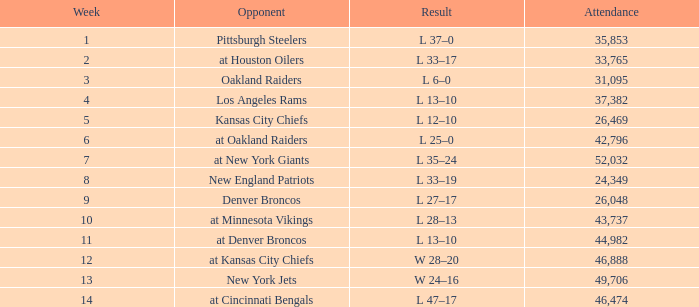Would you mind parsing the complete table? {'header': ['Week', 'Opponent', 'Result', 'Attendance'], 'rows': [['1', 'Pittsburgh Steelers', 'L 37–0', '35,853'], ['2', 'at Houston Oilers', 'L 33–17', '33,765'], ['3', 'Oakland Raiders', 'L 6–0', '31,095'], ['4', 'Los Angeles Rams', 'L 13–10', '37,382'], ['5', 'Kansas City Chiefs', 'L 12–10', '26,469'], ['6', 'at Oakland Raiders', 'L 25–0', '42,796'], ['7', 'at New York Giants', 'L 35–24', '52,032'], ['8', 'New England Patriots', 'L 33–19', '24,349'], ['9', 'Denver Broncos', 'L 27–17', '26,048'], ['10', 'at Minnesota Vikings', 'L 28–13', '43,737'], ['11', 'at Denver Broncos', 'L 13–10', '44,982'], ['12', 'at Kansas City Chiefs', 'W 28–20', '46,888'], ['13', 'New York Jets', 'W 24–16', '49,706'], ['14', 'at Cincinnati Bengals', 'L 47–17', '46,474']]} In which week was the minimum score recorded as 6-0? 3.0. 